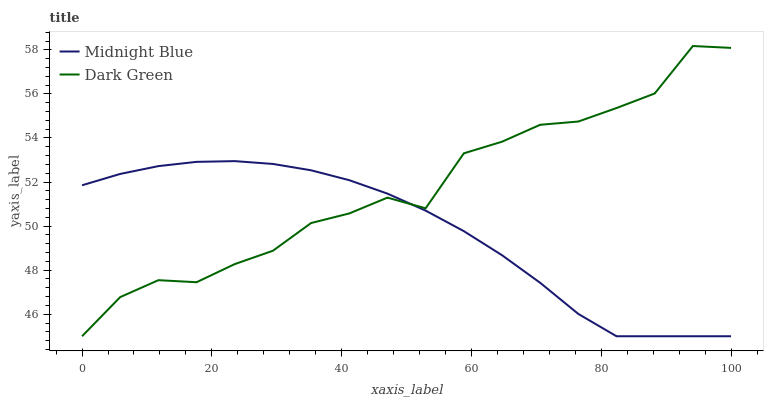Does Dark Green have the minimum area under the curve?
Answer yes or no. No. Is Dark Green the smoothest?
Answer yes or no. No. 